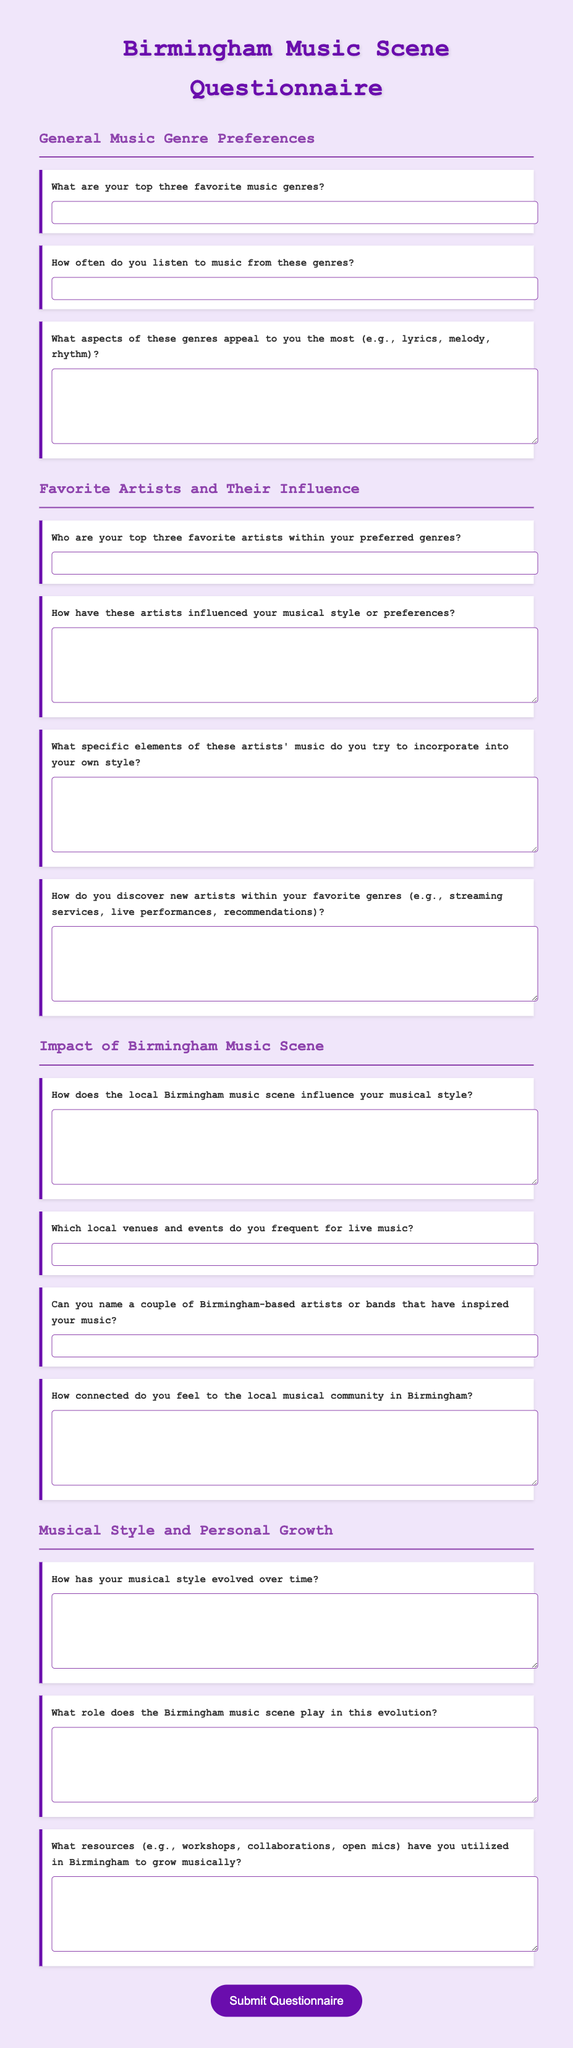What are the sections included in the questionnaire? The questionnaire consists of sections related to General Music Genre Preferences, Favorite Artists and Their Influence, Impact of Birmingham Music Scene, and Musical Style and Personal Growth.
Answer: General Music Genre Preferences, Favorite Artists and Their Influence, Impact of Birmingham Music Scene, Musical Style and Personal Growth How many questions are in the "Favorite Artists and Their Influence" section? There are four questions listed under the "Favorite Artists and Their Influence" section of the document.
Answer: 4 What is the color of the title in the document? The title color is defined as a specific shade (#6a0dad) in the CSS styling of the document.
Answer: #6a0dad What type of input fields are used for open-ended questions in the questionnaire? The open-ended questions utilize text input fields and textarea fields for responses in the questionnaire.
Answer: text input and textarea Which aspect of music genres is asked about in the second question of the General Music Genre Preferences section? The second question in this section asks about the frequency of music listening from the preferred genres.
Answer: frequency of music listening How does the questionnaire encourage participant interaction? The design features hover effects on the question boxes and an appealing submit button that changes color, enhancing user interaction.
Answer: Hover effects and color-changing submit button What is the purpose of the questionnaire? The document aims to gather insights and preferences related to music genres, artists, and the local Birmingham music scene from participating musicians.
Answer: Gather insights and preferences What resources are mentioned for musical growth in Birmingham? The questionnaire prompts participants to share information about workshops, collaborations, or open mics they have utilized in Birmingham.
Answer: Workshops, collaborations, open mics 